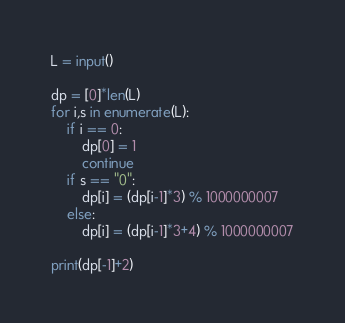<code> <loc_0><loc_0><loc_500><loc_500><_Python_>L = input()

dp = [0]*len(L)
for i,s in enumerate(L):
    if i == 0:
        dp[0] = 1
        continue
    if s == "0":
        dp[i] = (dp[i-1]*3) % 1000000007
    else:
        dp[i] = (dp[i-1]*3+4) % 1000000007

print(dp[-1]+2)
</code> 